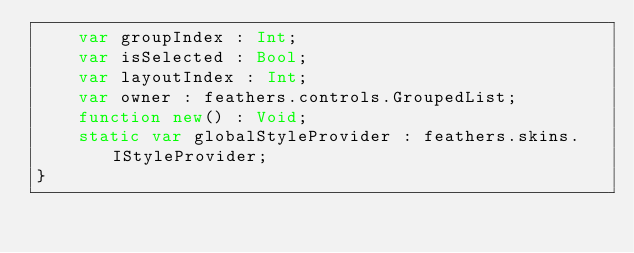<code> <loc_0><loc_0><loc_500><loc_500><_Haxe_>	var groupIndex : Int;
	var isSelected : Bool;
	var layoutIndex : Int;
	var owner : feathers.controls.GroupedList;
	function new() : Void;
	static var globalStyleProvider : feathers.skins.IStyleProvider;
}
</code> 